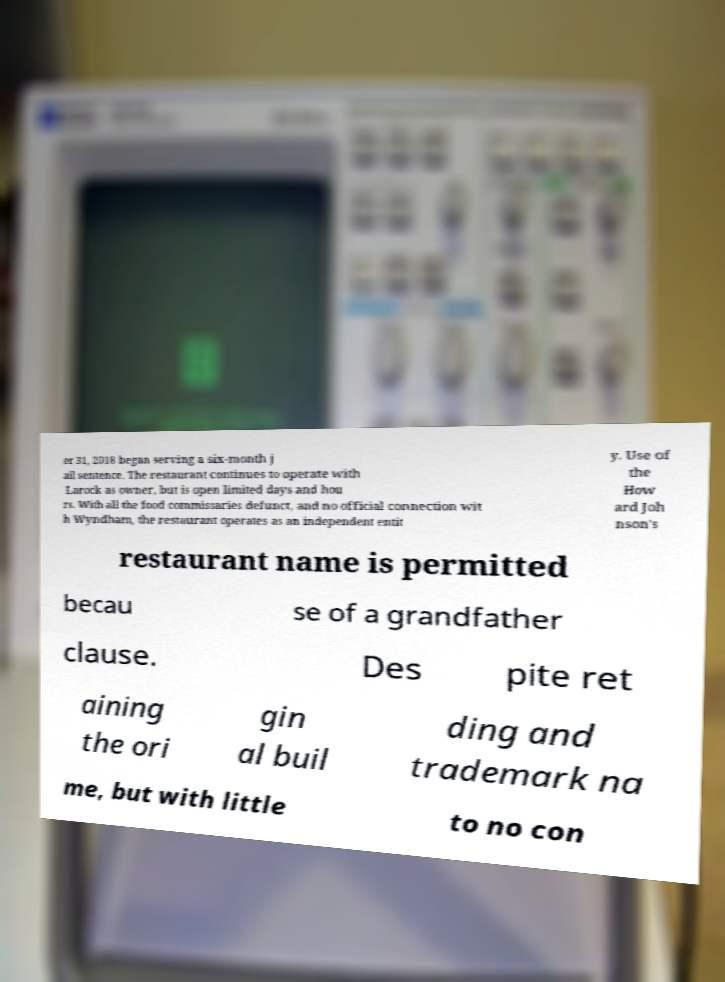What messages or text are displayed in this image? I need them in a readable, typed format. er 31, 2018 began serving a six-month j ail sentence. The restaurant continues to operate with Larock as owner, but is open limited days and hou rs. With all the food commissaries defunct, and no official connection wit h Wyndham, the restaurant operates as an independent entit y. Use of the How ard Joh nson's restaurant name is permitted becau se of a grandfather clause. Des pite ret aining the ori gin al buil ding and trademark na me, but with little to no con 